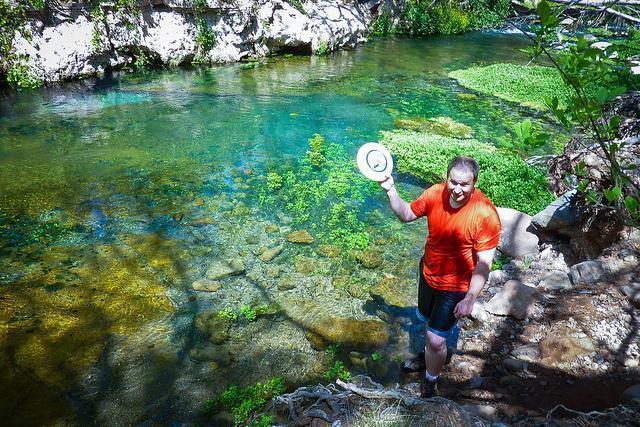How many elephants are behind the fence?
Give a very brief answer. 0. 